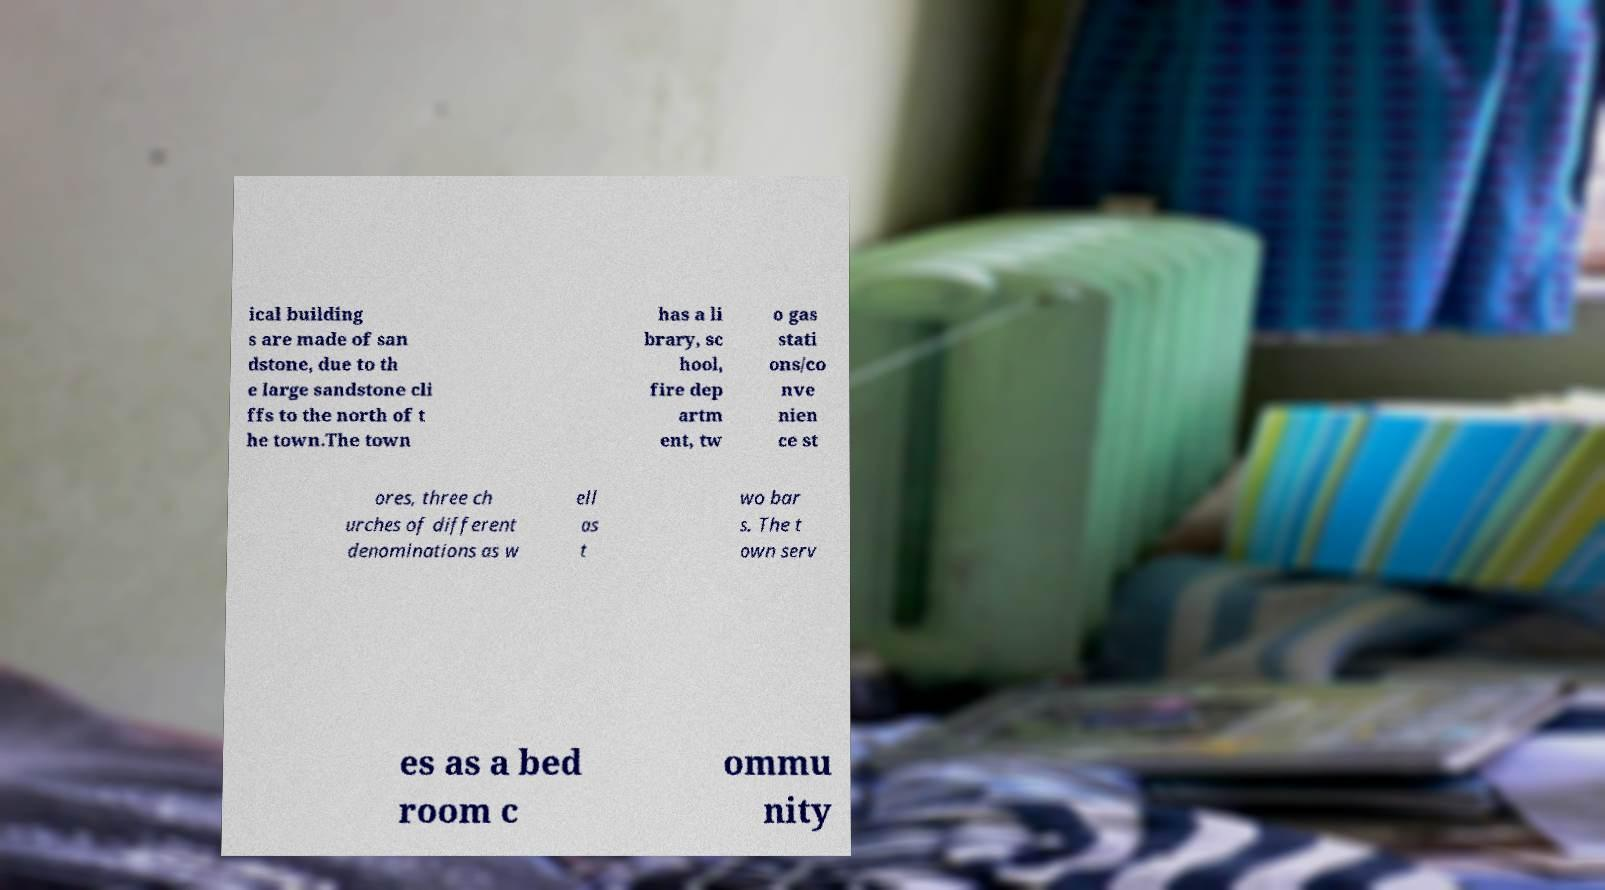Can you read and provide the text displayed in the image?This photo seems to have some interesting text. Can you extract and type it out for me? ical building s are made of san dstone, due to th e large sandstone cli ffs to the north of t he town.The town has a li brary, sc hool, fire dep artm ent, tw o gas stati ons/co nve nien ce st ores, three ch urches of different denominations as w ell as t wo bar s. The t own serv es as a bed room c ommu nity 